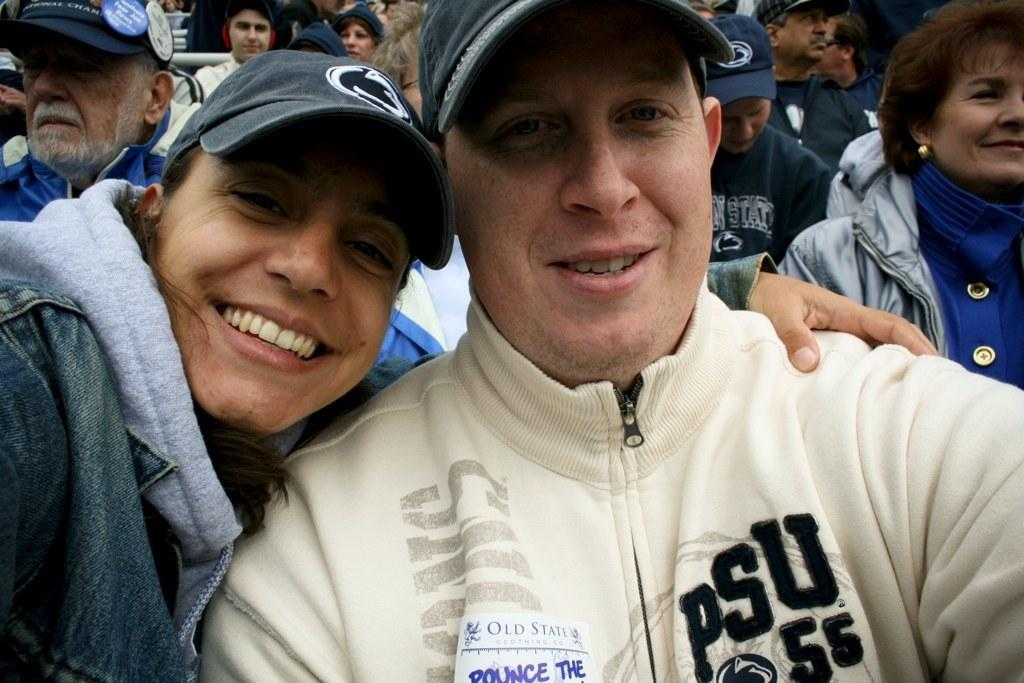What is the main subject of the image? The main subject of the image is a group of people. Can you describe the appearance of the person in the foreground wearing a white jacket and cap? The person in the foreground wearing a white jacket and cap is a male. Can you describe the appearance of the lady in the foreground wearing a blue jacket and cap? The lady in the foreground wearing a blue jacket and cap is also part of the group of people. What type of library can be seen in the background of the image? There is no library present in the image; it features a group of people. What unit of measurement is used to describe the height of the lady wearing a blue jacket and cap? The facts provided do not mention any specific unit of measurement for the lady's height. 